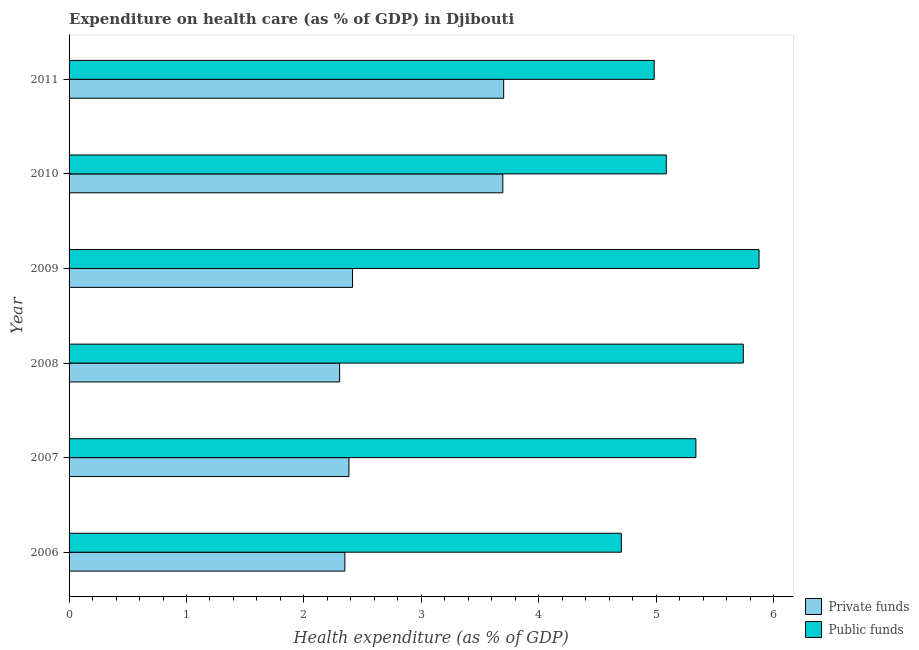How many different coloured bars are there?
Make the answer very short. 2. Are the number of bars per tick equal to the number of legend labels?
Provide a short and direct response. Yes. How many bars are there on the 5th tick from the bottom?
Give a very brief answer. 2. What is the amount of private funds spent in healthcare in 2009?
Provide a succinct answer. 2.41. Across all years, what is the maximum amount of private funds spent in healthcare?
Your answer should be compact. 3.7. Across all years, what is the minimum amount of private funds spent in healthcare?
Offer a terse response. 2.3. What is the total amount of public funds spent in healthcare in the graph?
Your response must be concise. 31.73. What is the difference between the amount of private funds spent in healthcare in 2007 and that in 2009?
Ensure brevity in your answer.  -0.03. What is the difference between the amount of private funds spent in healthcare in 2008 and the amount of public funds spent in healthcare in 2010?
Provide a short and direct response. -2.78. What is the average amount of private funds spent in healthcare per year?
Your answer should be very brief. 2.81. In the year 2006, what is the difference between the amount of public funds spent in healthcare and amount of private funds spent in healthcare?
Offer a terse response. 2.35. In how many years, is the amount of public funds spent in healthcare greater than 0.4 %?
Keep it short and to the point. 6. What is the ratio of the amount of private funds spent in healthcare in 2009 to that in 2010?
Your response must be concise. 0.65. Is the amount of private funds spent in healthcare in 2006 less than that in 2007?
Make the answer very short. Yes. What is the difference between the highest and the second highest amount of private funds spent in healthcare?
Provide a short and direct response. 0.01. Is the sum of the amount of private funds spent in healthcare in 2007 and 2009 greater than the maximum amount of public funds spent in healthcare across all years?
Ensure brevity in your answer.  No. What does the 1st bar from the top in 2006 represents?
Give a very brief answer. Public funds. What does the 1st bar from the bottom in 2006 represents?
Keep it short and to the point. Private funds. How many bars are there?
Keep it short and to the point. 12. Are the values on the major ticks of X-axis written in scientific E-notation?
Your answer should be compact. No. Does the graph contain grids?
Make the answer very short. No. Where does the legend appear in the graph?
Your answer should be very brief. Bottom right. What is the title of the graph?
Make the answer very short. Expenditure on health care (as % of GDP) in Djibouti. What is the label or title of the X-axis?
Your response must be concise. Health expenditure (as % of GDP). What is the label or title of the Y-axis?
Offer a terse response. Year. What is the Health expenditure (as % of GDP) of Private funds in 2006?
Your response must be concise. 2.35. What is the Health expenditure (as % of GDP) of Public funds in 2006?
Provide a short and direct response. 4.7. What is the Health expenditure (as % of GDP) in Private funds in 2007?
Offer a terse response. 2.38. What is the Health expenditure (as % of GDP) of Public funds in 2007?
Your answer should be compact. 5.34. What is the Health expenditure (as % of GDP) in Private funds in 2008?
Your answer should be very brief. 2.3. What is the Health expenditure (as % of GDP) of Public funds in 2008?
Your answer should be compact. 5.74. What is the Health expenditure (as % of GDP) in Private funds in 2009?
Provide a succinct answer. 2.41. What is the Health expenditure (as % of GDP) of Public funds in 2009?
Offer a terse response. 5.88. What is the Health expenditure (as % of GDP) in Private funds in 2010?
Offer a very short reply. 3.69. What is the Health expenditure (as % of GDP) of Public funds in 2010?
Keep it short and to the point. 5.09. What is the Health expenditure (as % of GDP) in Private funds in 2011?
Give a very brief answer. 3.7. What is the Health expenditure (as % of GDP) of Public funds in 2011?
Ensure brevity in your answer.  4.98. Across all years, what is the maximum Health expenditure (as % of GDP) in Private funds?
Ensure brevity in your answer.  3.7. Across all years, what is the maximum Health expenditure (as % of GDP) of Public funds?
Your response must be concise. 5.88. Across all years, what is the minimum Health expenditure (as % of GDP) of Private funds?
Your answer should be compact. 2.3. Across all years, what is the minimum Health expenditure (as % of GDP) of Public funds?
Your answer should be compact. 4.7. What is the total Health expenditure (as % of GDP) of Private funds in the graph?
Offer a very short reply. 16.84. What is the total Health expenditure (as % of GDP) of Public funds in the graph?
Keep it short and to the point. 31.73. What is the difference between the Health expenditure (as % of GDP) of Private funds in 2006 and that in 2007?
Provide a short and direct response. -0.03. What is the difference between the Health expenditure (as % of GDP) of Public funds in 2006 and that in 2007?
Offer a terse response. -0.63. What is the difference between the Health expenditure (as % of GDP) of Private funds in 2006 and that in 2008?
Provide a succinct answer. 0.04. What is the difference between the Health expenditure (as % of GDP) in Public funds in 2006 and that in 2008?
Provide a succinct answer. -1.04. What is the difference between the Health expenditure (as % of GDP) in Private funds in 2006 and that in 2009?
Make the answer very short. -0.07. What is the difference between the Health expenditure (as % of GDP) in Public funds in 2006 and that in 2009?
Offer a terse response. -1.17. What is the difference between the Health expenditure (as % of GDP) of Private funds in 2006 and that in 2010?
Provide a succinct answer. -1.35. What is the difference between the Health expenditure (as % of GDP) of Public funds in 2006 and that in 2010?
Provide a short and direct response. -0.38. What is the difference between the Health expenditure (as % of GDP) of Private funds in 2006 and that in 2011?
Offer a terse response. -1.35. What is the difference between the Health expenditure (as % of GDP) of Public funds in 2006 and that in 2011?
Give a very brief answer. -0.28. What is the difference between the Health expenditure (as % of GDP) of Private funds in 2007 and that in 2008?
Your answer should be compact. 0.08. What is the difference between the Health expenditure (as % of GDP) of Public funds in 2007 and that in 2008?
Your answer should be very brief. -0.4. What is the difference between the Health expenditure (as % of GDP) of Private funds in 2007 and that in 2009?
Provide a succinct answer. -0.03. What is the difference between the Health expenditure (as % of GDP) of Public funds in 2007 and that in 2009?
Ensure brevity in your answer.  -0.54. What is the difference between the Health expenditure (as % of GDP) in Private funds in 2007 and that in 2010?
Give a very brief answer. -1.31. What is the difference between the Health expenditure (as % of GDP) in Public funds in 2007 and that in 2010?
Keep it short and to the point. 0.25. What is the difference between the Health expenditure (as % of GDP) of Private funds in 2007 and that in 2011?
Ensure brevity in your answer.  -1.32. What is the difference between the Health expenditure (as % of GDP) of Public funds in 2007 and that in 2011?
Keep it short and to the point. 0.35. What is the difference between the Health expenditure (as % of GDP) of Private funds in 2008 and that in 2009?
Ensure brevity in your answer.  -0.11. What is the difference between the Health expenditure (as % of GDP) in Public funds in 2008 and that in 2009?
Your answer should be very brief. -0.13. What is the difference between the Health expenditure (as % of GDP) in Private funds in 2008 and that in 2010?
Provide a short and direct response. -1.39. What is the difference between the Health expenditure (as % of GDP) in Public funds in 2008 and that in 2010?
Offer a very short reply. 0.66. What is the difference between the Health expenditure (as % of GDP) in Private funds in 2008 and that in 2011?
Your answer should be compact. -1.4. What is the difference between the Health expenditure (as % of GDP) in Public funds in 2008 and that in 2011?
Your answer should be compact. 0.76. What is the difference between the Health expenditure (as % of GDP) in Private funds in 2009 and that in 2010?
Your answer should be compact. -1.28. What is the difference between the Health expenditure (as % of GDP) in Public funds in 2009 and that in 2010?
Offer a terse response. 0.79. What is the difference between the Health expenditure (as % of GDP) in Private funds in 2009 and that in 2011?
Your answer should be very brief. -1.29. What is the difference between the Health expenditure (as % of GDP) of Public funds in 2009 and that in 2011?
Offer a terse response. 0.89. What is the difference between the Health expenditure (as % of GDP) in Private funds in 2010 and that in 2011?
Offer a terse response. -0.01. What is the difference between the Health expenditure (as % of GDP) in Public funds in 2010 and that in 2011?
Offer a terse response. 0.1. What is the difference between the Health expenditure (as % of GDP) in Private funds in 2006 and the Health expenditure (as % of GDP) in Public funds in 2007?
Make the answer very short. -2.99. What is the difference between the Health expenditure (as % of GDP) of Private funds in 2006 and the Health expenditure (as % of GDP) of Public funds in 2008?
Offer a terse response. -3.39. What is the difference between the Health expenditure (as % of GDP) in Private funds in 2006 and the Health expenditure (as % of GDP) in Public funds in 2009?
Your response must be concise. -3.53. What is the difference between the Health expenditure (as % of GDP) of Private funds in 2006 and the Health expenditure (as % of GDP) of Public funds in 2010?
Offer a very short reply. -2.74. What is the difference between the Health expenditure (as % of GDP) in Private funds in 2006 and the Health expenditure (as % of GDP) in Public funds in 2011?
Keep it short and to the point. -2.63. What is the difference between the Health expenditure (as % of GDP) in Private funds in 2007 and the Health expenditure (as % of GDP) in Public funds in 2008?
Your answer should be very brief. -3.36. What is the difference between the Health expenditure (as % of GDP) of Private funds in 2007 and the Health expenditure (as % of GDP) of Public funds in 2009?
Give a very brief answer. -3.49. What is the difference between the Health expenditure (as % of GDP) in Private funds in 2007 and the Health expenditure (as % of GDP) in Public funds in 2010?
Your response must be concise. -2.7. What is the difference between the Health expenditure (as % of GDP) of Private funds in 2007 and the Health expenditure (as % of GDP) of Public funds in 2011?
Offer a very short reply. -2.6. What is the difference between the Health expenditure (as % of GDP) of Private funds in 2008 and the Health expenditure (as % of GDP) of Public funds in 2009?
Offer a terse response. -3.57. What is the difference between the Health expenditure (as % of GDP) of Private funds in 2008 and the Health expenditure (as % of GDP) of Public funds in 2010?
Offer a very short reply. -2.78. What is the difference between the Health expenditure (as % of GDP) of Private funds in 2008 and the Health expenditure (as % of GDP) of Public funds in 2011?
Provide a succinct answer. -2.68. What is the difference between the Health expenditure (as % of GDP) of Private funds in 2009 and the Health expenditure (as % of GDP) of Public funds in 2010?
Provide a short and direct response. -2.67. What is the difference between the Health expenditure (as % of GDP) of Private funds in 2009 and the Health expenditure (as % of GDP) of Public funds in 2011?
Your answer should be compact. -2.57. What is the difference between the Health expenditure (as % of GDP) in Private funds in 2010 and the Health expenditure (as % of GDP) in Public funds in 2011?
Your answer should be very brief. -1.29. What is the average Health expenditure (as % of GDP) of Private funds per year?
Your response must be concise. 2.81. What is the average Health expenditure (as % of GDP) of Public funds per year?
Give a very brief answer. 5.29. In the year 2006, what is the difference between the Health expenditure (as % of GDP) of Private funds and Health expenditure (as % of GDP) of Public funds?
Your response must be concise. -2.35. In the year 2007, what is the difference between the Health expenditure (as % of GDP) in Private funds and Health expenditure (as % of GDP) in Public funds?
Ensure brevity in your answer.  -2.95. In the year 2008, what is the difference between the Health expenditure (as % of GDP) in Private funds and Health expenditure (as % of GDP) in Public funds?
Provide a succinct answer. -3.44. In the year 2009, what is the difference between the Health expenditure (as % of GDP) in Private funds and Health expenditure (as % of GDP) in Public funds?
Your response must be concise. -3.46. In the year 2010, what is the difference between the Health expenditure (as % of GDP) of Private funds and Health expenditure (as % of GDP) of Public funds?
Your response must be concise. -1.39. In the year 2011, what is the difference between the Health expenditure (as % of GDP) of Private funds and Health expenditure (as % of GDP) of Public funds?
Provide a succinct answer. -1.28. What is the ratio of the Health expenditure (as % of GDP) of Private funds in 2006 to that in 2007?
Offer a terse response. 0.99. What is the ratio of the Health expenditure (as % of GDP) in Public funds in 2006 to that in 2007?
Provide a short and direct response. 0.88. What is the ratio of the Health expenditure (as % of GDP) of Private funds in 2006 to that in 2008?
Give a very brief answer. 1.02. What is the ratio of the Health expenditure (as % of GDP) of Public funds in 2006 to that in 2008?
Offer a terse response. 0.82. What is the ratio of the Health expenditure (as % of GDP) in Private funds in 2006 to that in 2009?
Your answer should be compact. 0.97. What is the ratio of the Health expenditure (as % of GDP) in Public funds in 2006 to that in 2009?
Ensure brevity in your answer.  0.8. What is the ratio of the Health expenditure (as % of GDP) in Private funds in 2006 to that in 2010?
Your answer should be very brief. 0.64. What is the ratio of the Health expenditure (as % of GDP) of Public funds in 2006 to that in 2010?
Provide a succinct answer. 0.92. What is the ratio of the Health expenditure (as % of GDP) of Private funds in 2006 to that in 2011?
Provide a succinct answer. 0.63. What is the ratio of the Health expenditure (as % of GDP) of Public funds in 2006 to that in 2011?
Make the answer very short. 0.94. What is the ratio of the Health expenditure (as % of GDP) of Private funds in 2007 to that in 2008?
Provide a short and direct response. 1.03. What is the ratio of the Health expenditure (as % of GDP) of Public funds in 2007 to that in 2008?
Your answer should be very brief. 0.93. What is the ratio of the Health expenditure (as % of GDP) in Private funds in 2007 to that in 2009?
Your answer should be compact. 0.99. What is the ratio of the Health expenditure (as % of GDP) of Public funds in 2007 to that in 2009?
Provide a succinct answer. 0.91. What is the ratio of the Health expenditure (as % of GDP) in Private funds in 2007 to that in 2010?
Keep it short and to the point. 0.65. What is the ratio of the Health expenditure (as % of GDP) of Public funds in 2007 to that in 2010?
Ensure brevity in your answer.  1.05. What is the ratio of the Health expenditure (as % of GDP) in Private funds in 2007 to that in 2011?
Your answer should be very brief. 0.64. What is the ratio of the Health expenditure (as % of GDP) of Public funds in 2007 to that in 2011?
Your answer should be very brief. 1.07. What is the ratio of the Health expenditure (as % of GDP) in Private funds in 2008 to that in 2009?
Keep it short and to the point. 0.95. What is the ratio of the Health expenditure (as % of GDP) in Public funds in 2008 to that in 2009?
Provide a short and direct response. 0.98. What is the ratio of the Health expenditure (as % of GDP) in Private funds in 2008 to that in 2010?
Offer a terse response. 0.62. What is the ratio of the Health expenditure (as % of GDP) of Public funds in 2008 to that in 2010?
Ensure brevity in your answer.  1.13. What is the ratio of the Health expenditure (as % of GDP) of Private funds in 2008 to that in 2011?
Offer a terse response. 0.62. What is the ratio of the Health expenditure (as % of GDP) of Public funds in 2008 to that in 2011?
Make the answer very short. 1.15. What is the ratio of the Health expenditure (as % of GDP) in Private funds in 2009 to that in 2010?
Your answer should be very brief. 0.65. What is the ratio of the Health expenditure (as % of GDP) in Public funds in 2009 to that in 2010?
Your response must be concise. 1.16. What is the ratio of the Health expenditure (as % of GDP) of Private funds in 2009 to that in 2011?
Provide a short and direct response. 0.65. What is the ratio of the Health expenditure (as % of GDP) of Public funds in 2009 to that in 2011?
Offer a very short reply. 1.18. What is the ratio of the Health expenditure (as % of GDP) in Private funds in 2010 to that in 2011?
Offer a terse response. 1. What is the ratio of the Health expenditure (as % of GDP) of Public funds in 2010 to that in 2011?
Your response must be concise. 1.02. What is the difference between the highest and the second highest Health expenditure (as % of GDP) of Private funds?
Keep it short and to the point. 0.01. What is the difference between the highest and the second highest Health expenditure (as % of GDP) in Public funds?
Ensure brevity in your answer.  0.13. What is the difference between the highest and the lowest Health expenditure (as % of GDP) in Private funds?
Your response must be concise. 1.4. What is the difference between the highest and the lowest Health expenditure (as % of GDP) of Public funds?
Ensure brevity in your answer.  1.17. 